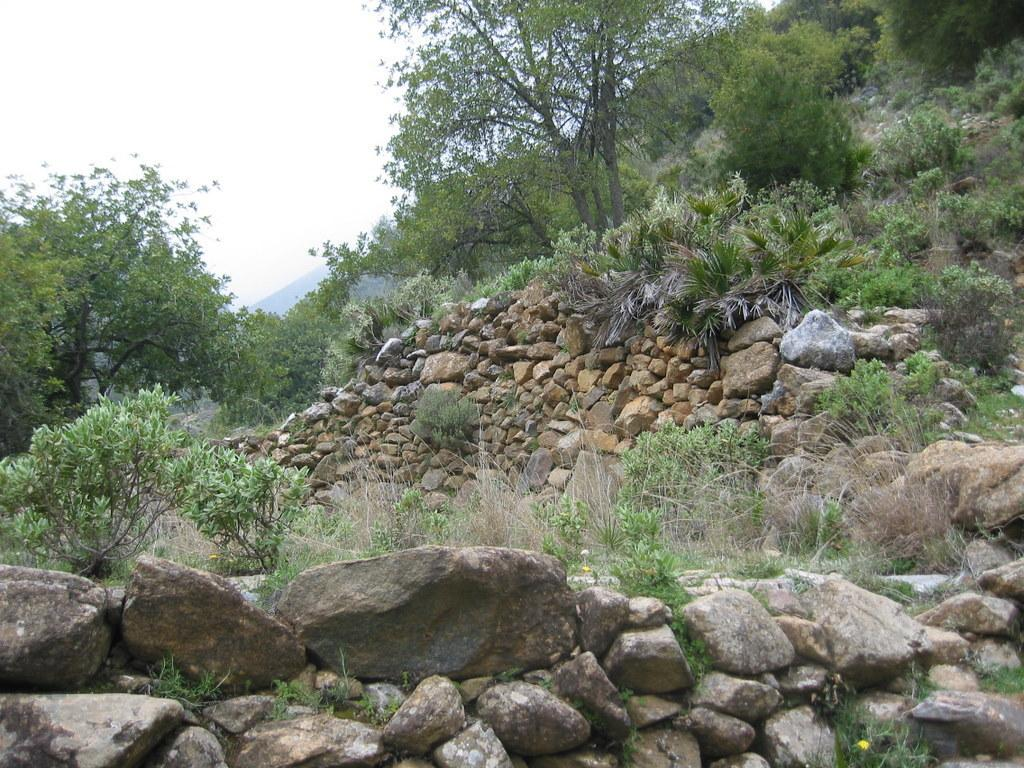What can be seen in the foreground of the image? There are stones and trees in the foreground of the image. What else is present in the foreground of the image? There are also trees in the foreground of the image. What is visible in the background of the image? There are trees in the background of the image. What can be seen at the top of the image? The sky is visible at the top of the image. What type of exchange is taking place between the trees in the image? There is no exchange taking place between the trees in the image, as trees do not engage in exchanges. Can you tell me how many veins are visible in the image? There are no veins visible in the image, as it features stones, trees, and the sky. 